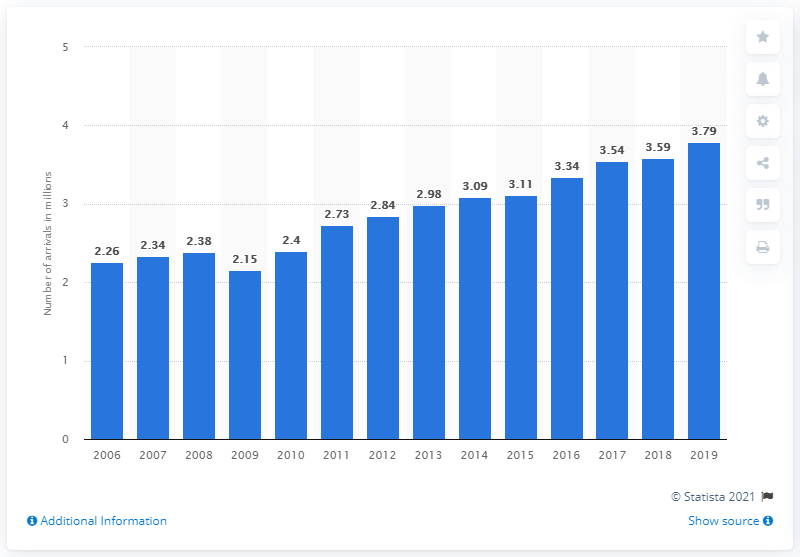Draw attention to some important aspects in this diagram. In 2019, a total of 3.79 tourists arrived at accommodation establishments in Estonia. 